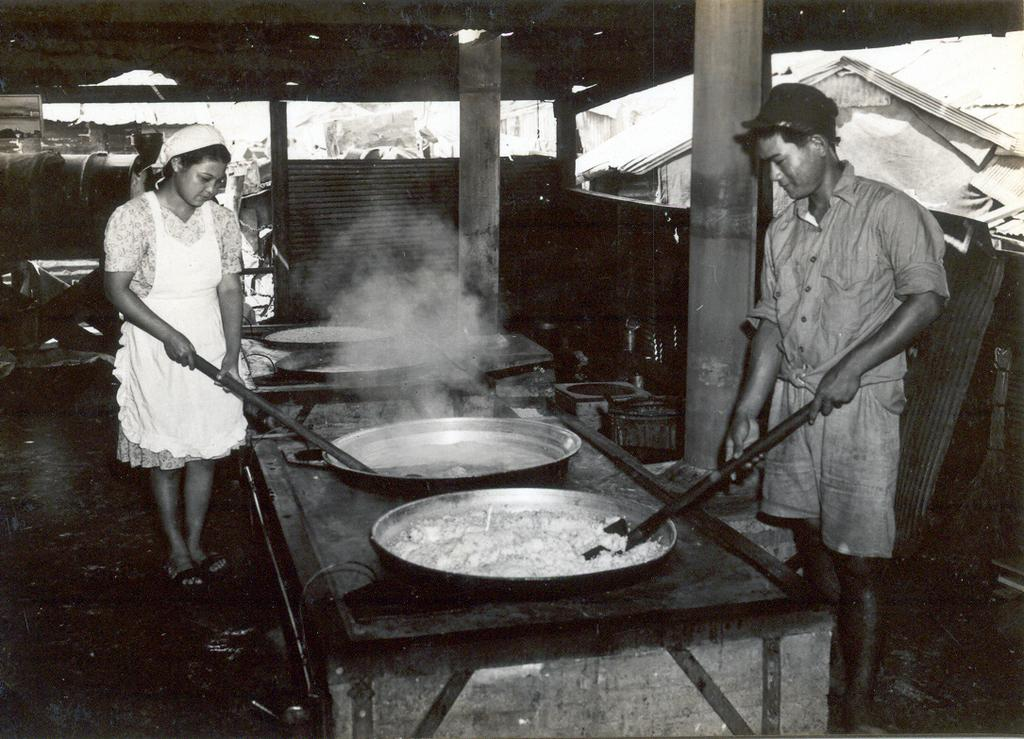Who is present in the image? There are people in the image. What are the people doing in the image? The people are cooking. What objects are in front of the people? There are bowls in front of the people. What are the people holding in their hands? The people are holding sticks. What can be seen in the distance in the image? There are houses visible in the background of the image. What type of lettuce is being used in the cooking process in the image? There is no lettuce visible in the image; the people are holding sticks and cooking with bowls in front of them. 